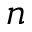Convert formula to latex. <formula><loc_0><loc_0><loc_500><loc_500>n</formula> 